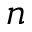Convert formula to latex. <formula><loc_0><loc_0><loc_500><loc_500>n</formula> 